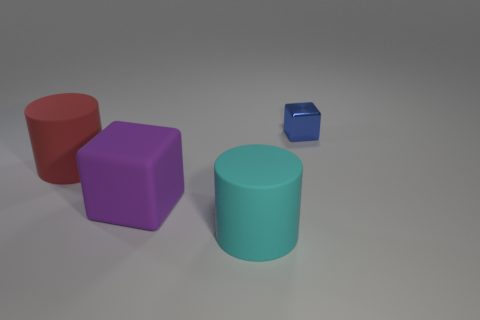Add 3 large purple blocks. How many objects exist? 7 Add 1 large blocks. How many large blocks exist? 2 Subtract 0 green cylinders. How many objects are left? 4 Subtract all small blue shiny objects. Subtract all big matte blocks. How many objects are left? 2 Add 3 red objects. How many red objects are left? 4 